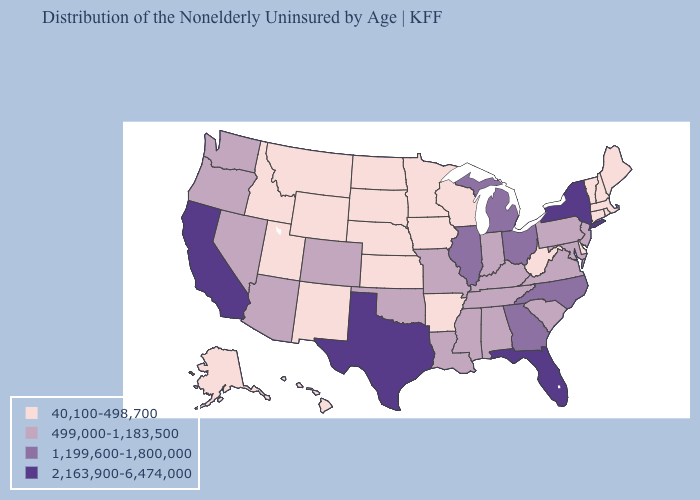Among the states that border Arkansas , which have the lowest value?
Short answer required. Louisiana, Mississippi, Missouri, Oklahoma, Tennessee. Which states have the lowest value in the Northeast?
Concise answer only. Connecticut, Maine, Massachusetts, New Hampshire, Rhode Island, Vermont. Name the states that have a value in the range 40,100-498,700?
Concise answer only. Alaska, Arkansas, Connecticut, Delaware, Hawaii, Idaho, Iowa, Kansas, Maine, Massachusetts, Minnesota, Montana, Nebraska, New Hampshire, New Mexico, North Dakota, Rhode Island, South Dakota, Utah, Vermont, West Virginia, Wisconsin, Wyoming. Name the states that have a value in the range 2,163,900-6,474,000?
Keep it brief. California, Florida, New York, Texas. What is the highest value in the MidWest ?
Answer briefly. 1,199,600-1,800,000. Does Alaska have the same value as Illinois?
Give a very brief answer. No. Among the states that border Pennsylvania , which have the highest value?
Give a very brief answer. New York. Among the states that border Indiana , which have the highest value?
Quick response, please. Illinois, Michigan, Ohio. Does Nebraska have the highest value in the MidWest?
Keep it brief. No. What is the highest value in the USA?
Concise answer only. 2,163,900-6,474,000. Does Georgia have a higher value than Alabama?
Give a very brief answer. Yes. Does Indiana have the lowest value in the MidWest?
Give a very brief answer. No. Name the states that have a value in the range 1,199,600-1,800,000?
Concise answer only. Georgia, Illinois, Michigan, North Carolina, Ohio. Name the states that have a value in the range 1,199,600-1,800,000?
Give a very brief answer. Georgia, Illinois, Michigan, North Carolina, Ohio. Name the states that have a value in the range 2,163,900-6,474,000?
Short answer required. California, Florida, New York, Texas. 